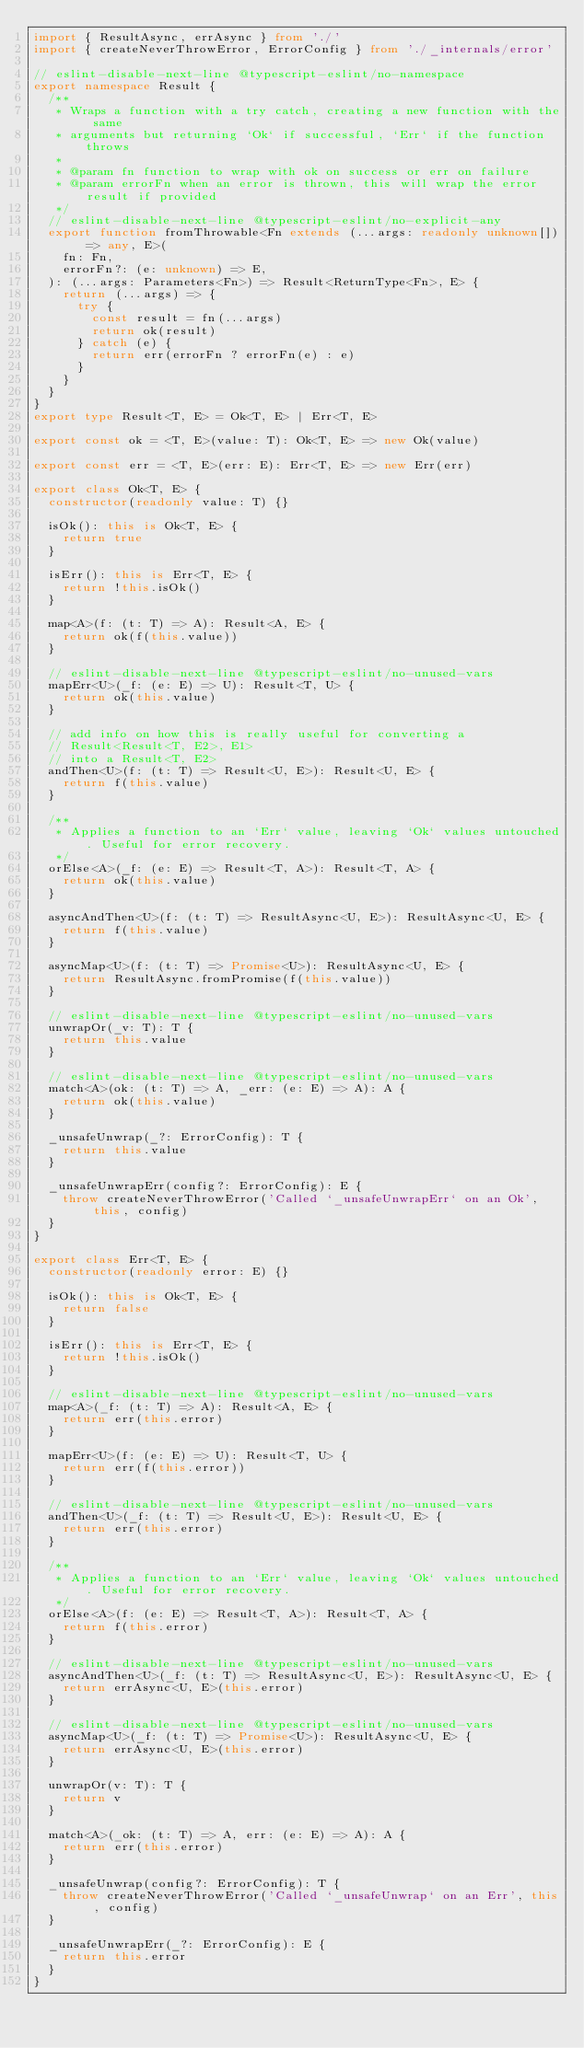<code> <loc_0><loc_0><loc_500><loc_500><_TypeScript_>import { ResultAsync, errAsync } from './'
import { createNeverThrowError, ErrorConfig } from './_internals/error'

// eslint-disable-next-line @typescript-eslint/no-namespace
export namespace Result {
  /**
   * Wraps a function with a try catch, creating a new function with the same
   * arguments but returning `Ok` if successful, `Err` if the function throws
   *
   * @param fn function to wrap with ok on success or err on failure
   * @param errorFn when an error is thrown, this will wrap the error result if provided
   */
  // eslint-disable-next-line @typescript-eslint/no-explicit-any
  export function fromThrowable<Fn extends (...args: readonly unknown[]) => any, E>(
    fn: Fn,
    errorFn?: (e: unknown) => E,
  ): (...args: Parameters<Fn>) => Result<ReturnType<Fn>, E> {
    return (...args) => {
      try {
        const result = fn(...args)
        return ok(result)
      } catch (e) {
        return err(errorFn ? errorFn(e) : e)
      }
    }
  }
}
export type Result<T, E> = Ok<T, E> | Err<T, E>

export const ok = <T, E>(value: T): Ok<T, E> => new Ok(value)

export const err = <T, E>(err: E): Err<T, E> => new Err(err)

export class Ok<T, E> {
  constructor(readonly value: T) {}

  isOk(): this is Ok<T, E> {
    return true
  }

  isErr(): this is Err<T, E> {
    return !this.isOk()
  }

  map<A>(f: (t: T) => A): Result<A, E> {
    return ok(f(this.value))
  }

  // eslint-disable-next-line @typescript-eslint/no-unused-vars
  mapErr<U>(_f: (e: E) => U): Result<T, U> {
    return ok(this.value)
  }

  // add info on how this is really useful for converting a
  // Result<Result<T, E2>, E1>
  // into a Result<T, E2>
  andThen<U>(f: (t: T) => Result<U, E>): Result<U, E> {
    return f(this.value)
  }

  /**
   * Applies a function to an `Err` value, leaving `Ok` values untouched. Useful for error recovery.
   */
  orElse<A>(_f: (e: E) => Result<T, A>): Result<T, A> {
    return ok(this.value)
  }

  asyncAndThen<U>(f: (t: T) => ResultAsync<U, E>): ResultAsync<U, E> {
    return f(this.value)
  }

  asyncMap<U>(f: (t: T) => Promise<U>): ResultAsync<U, E> {
    return ResultAsync.fromPromise(f(this.value))
  }

  // eslint-disable-next-line @typescript-eslint/no-unused-vars
  unwrapOr(_v: T): T {
    return this.value
  }

  // eslint-disable-next-line @typescript-eslint/no-unused-vars
  match<A>(ok: (t: T) => A, _err: (e: E) => A): A {
    return ok(this.value)
  }

  _unsafeUnwrap(_?: ErrorConfig): T {
    return this.value
  }

  _unsafeUnwrapErr(config?: ErrorConfig): E {
    throw createNeverThrowError('Called `_unsafeUnwrapErr` on an Ok', this, config)
  }
}

export class Err<T, E> {
  constructor(readonly error: E) {}

  isOk(): this is Ok<T, E> {
    return false
  }

  isErr(): this is Err<T, E> {
    return !this.isOk()
  }

  // eslint-disable-next-line @typescript-eslint/no-unused-vars
  map<A>(_f: (t: T) => A): Result<A, E> {
    return err(this.error)
  }

  mapErr<U>(f: (e: E) => U): Result<T, U> {
    return err(f(this.error))
  }

  // eslint-disable-next-line @typescript-eslint/no-unused-vars
  andThen<U>(_f: (t: T) => Result<U, E>): Result<U, E> {
    return err(this.error)
  }

  /**
   * Applies a function to an `Err` value, leaving `Ok` values untouched. Useful for error recovery.
   */
  orElse<A>(f: (e: E) => Result<T, A>): Result<T, A> {
    return f(this.error)
  }

  // eslint-disable-next-line @typescript-eslint/no-unused-vars
  asyncAndThen<U>(_f: (t: T) => ResultAsync<U, E>): ResultAsync<U, E> {
    return errAsync<U, E>(this.error)
  }

  // eslint-disable-next-line @typescript-eslint/no-unused-vars
  asyncMap<U>(_f: (t: T) => Promise<U>): ResultAsync<U, E> {
    return errAsync<U, E>(this.error)
  }

  unwrapOr(v: T): T {
    return v
  }

  match<A>(_ok: (t: T) => A, err: (e: E) => A): A {
    return err(this.error)
  }

  _unsafeUnwrap(config?: ErrorConfig): T {
    throw createNeverThrowError('Called `_unsafeUnwrap` on an Err', this, config)
  }

  _unsafeUnwrapErr(_?: ErrorConfig): E {
    return this.error
  }
}
</code> 